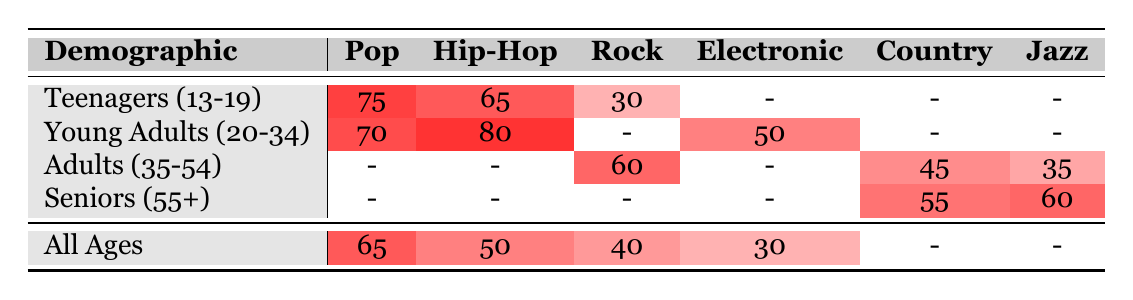What is the most popular music genre among teenagers? The table indicates that Pop has the highest popularity score among teenagers (13-19) with a score of 75.
Answer: Pop Which genre is most popular among young adults aged 20-34? According to the table, Hip-Hop is the most popular genre among young adults (20-34) with a popularity score of 80.
Answer: Hip-Hop How does the popularity of Jazz compare between seniors (55+) and adults (35-54)? The table shows that Jazz has a popularity score of 60 among seniors (55+) and a score of 35 among adults (35-54). The seniors have a higher popularity score by 25 points.
Answer: Seniors have 25 points higher What is the average popularity score of Pop across all demographics listed? The table provides the following Pop scores: 75, 70, 65. To find the average, we add the scores (75 + 70 + 65) = 210, then divide by the number of groups (3) which gives us 210/3 = 70.
Answer: 70 Is Country music more popular among seniors (55+) than adults (35-54)? Seniors have a popularity score of 55 for Country music, while adults have a score of 45, which confirms that Country is more popular among seniors.
Answer: Yes What is the least popular genre according to the table for all age groups? For all ages, the least popular genre is Folk with a popularity score of 25. Looking at other scores, none are lower.
Answer: Folk What is the difference in popularity scores between Hip-Hop and Rock for teenagers? Teenagers have a popularity score of 65 for Hip-Hop and 30 for Rock. The difference is calculated as 65 - 30 = 35.
Answer: 35 Which demographic has the highest overall popularity score for Electronic music? The table shows Electronic as having a popularity score of 50 among young adults (20-34) and lower scores in other demographics (30 for all ages, zero for the rest), making young adults the demographic with the highest score.
Answer: Young Adults (20-34) What is the combined popularity score for Rock among teenagers and adults (35-54)? The table indicates that teenagers have a Rock score of 30, while adults score 60. The total is calculated by adding the scores: 30 + 60 = 90.
Answer: 90 